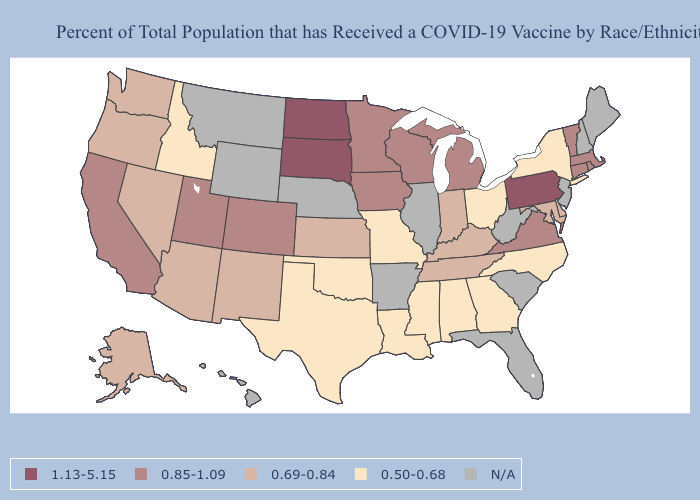Does the first symbol in the legend represent the smallest category?
Concise answer only. No. Name the states that have a value in the range N/A?
Quick response, please. Arkansas, Florida, Hawaii, Illinois, Maine, Montana, Nebraska, New Hampshire, New Jersey, South Carolina, West Virginia, Wyoming. What is the lowest value in the USA?
Short answer required. 0.50-0.68. What is the value of Iowa?
Answer briefly. 0.85-1.09. What is the highest value in states that border Nebraska?
Short answer required. 1.13-5.15. How many symbols are there in the legend?
Write a very short answer. 5. What is the value of Delaware?
Give a very brief answer. 0.69-0.84. What is the lowest value in the MidWest?
Give a very brief answer. 0.50-0.68. What is the lowest value in the MidWest?
Answer briefly. 0.50-0.68. Name the states that have a value in the range 1.13-5.15?
Give a very brief answer. North Dakota, Pennsylvania, South Dakota. Which states hav the highest value in the South?
Concise answer only. Virginia. What is the lowest value in the West?
Be succinct. 0.50-0.68. What is the value of West Virginia?
Concise answer only. N/A. Which states have the highest value in the USA?
Concise answer only. North Dakota, Pennsylvania, South Dakota. 